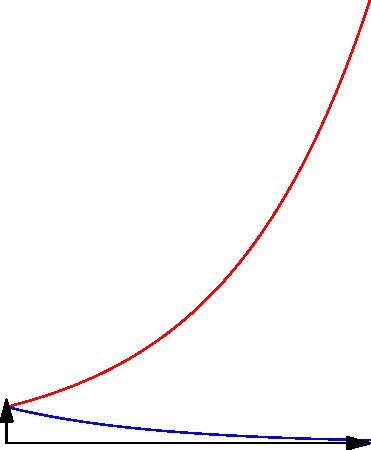In the context of income distribution analysis, the graph shows two curves: an original blue curve and a red curve. If the red curve is a reflection of the blue curve, about which axis has this reflection occurred? How does this transformation affect the interpretation of income inequality? To determine the axis of reflection and interpret its sociological implications, let's follow these steps:

1. Observe the curves:
   - The blue curve decreases from left to right
   - The red curve increases from left to right

2. Identify the transformation:
   - The red curve appears to be a mirror image of the blue curve
   - This suggests a reflection has occurred

3. Determine the axis of reflection:
   - The curves intersect at x = 0 (the y-axis)
   - They are symmetrical about the y-axis
   - Therefore, the reflection occurred about the y-axis

4. Interpret the transformation:
   - The original blue curve represents a typical income distribution where:
     * Many people have low incomes (left side)
     * Fewer people have high incomes (right side)
   - The reflected red curve inverts this distribution:
     * Many people have high incomes
     * Fewer people have low incomes

5. Analyze the implications for income inequality:
   - The reflection transforms a right-skewed distribution (blue) into a left-skewed distribution (red)
   - This implies a dramatic shift in income equality:
     * From a society with high inequality (blue curve)
     * To a society with much lower inequality (red curve)

6. Sociological interpretation:
   - The reflection represents an idealized transformation of society
   - It illustrates how income distribution would change if wealth were more evenly distributed
   - This transformation is relevant to discussions on wealth redistribution policies and their potential effects on society
Answer: The reflection occurred about the y-axis, transforming a high-inequality distribution into a low-inequality distribution. 